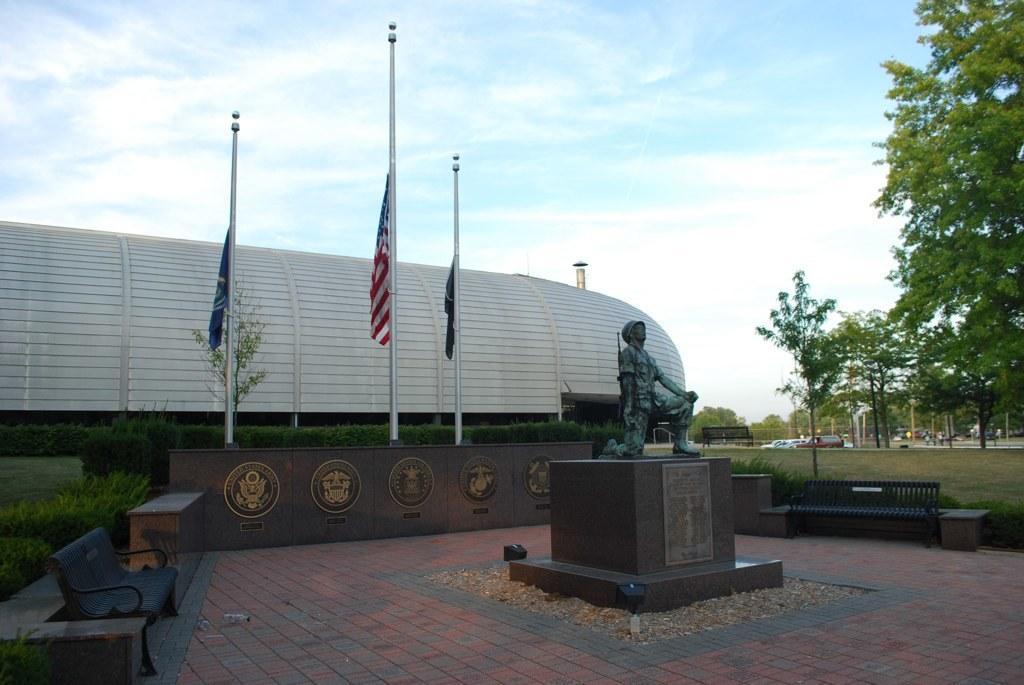Could you give a brief overview of what you see in this image? In this image we can see a pillar with statue and a board with text on the pillar, there are few benches, in the background there is a wall with some logos and flags on the wall, there are few plants trees and a building, there are vehicles on the road and sky on the top. 